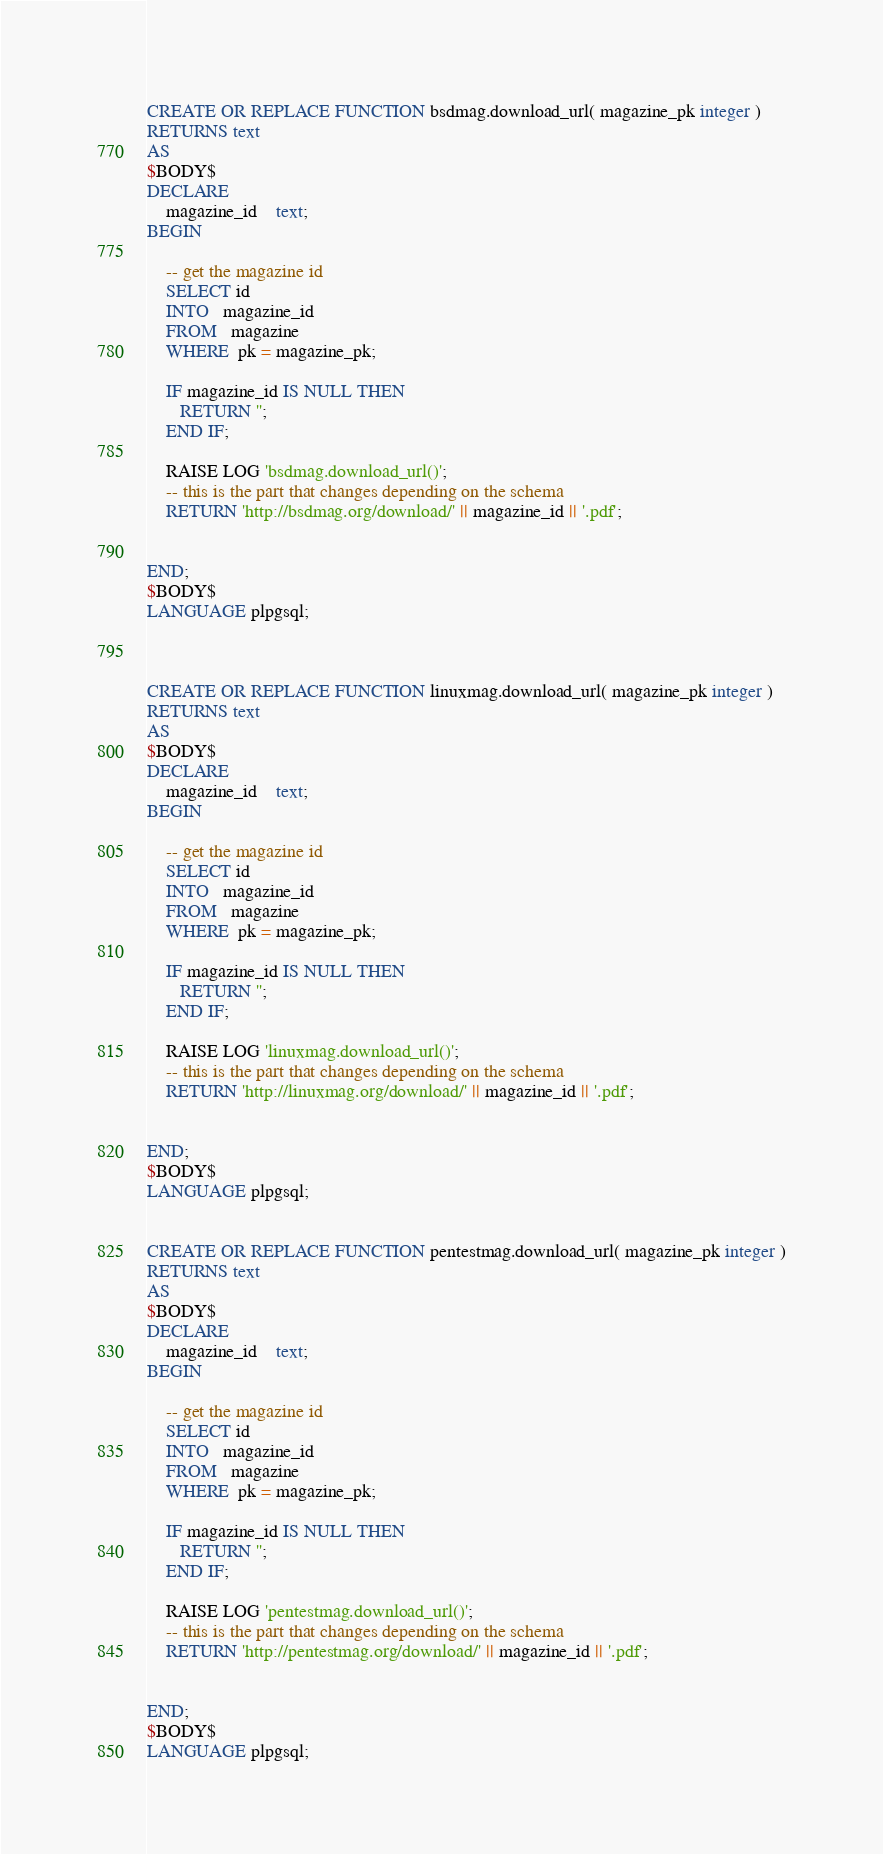<code> <loc_0><loc_0><loc_500><loc_500><_SQL_>CREATE OR REPLACE FUNCTION bsdmag.download_url( magazine_pk integer )
RETURNS text
AS
$BODY$
DECLARE
	magazine_id	text;
BEGIN

	-- get the magazine id
	SELECT id
	INTO   magazine_id
	FROM   magazine
	WHERE  pk = magazine_pk;

	IF magazine_id IS NULL THEN
	   RETURN '';
	END IF;
	
	RAISE LOG 'bsdmag.download_url()';
	-- this is the part that changes depending on the schema
	RETURN 'http://bsdmag.org/download/' || magazine_id || '.pdf';	
	

END;
$BODY$
LANGUAGE plpgsql;



CREATE OR REPLACE FUNCTION linuxmag.download_url( magazine_pk integer )
RETURNS text
AS
$BODY$
DECLARE
	magazine_id	text;
BEGIN

	-- get the magazine id
	SELECT id
	INTO   magazine_id
	FROM   magazine
	WHERE  pk = magazine_pk;

	IF magazine_id IS NULL THEN
	   RETURN '';
	END IF;

	RAISE LOG 'linuxmag.download_url()';
	-- this is the part that changes depending on the schema
	RETURN 'http://linuxmag.org/download/' || magazine_id || '.pdf';	
	

END;
$BODY$
LANGUAGE plpgsql;


CREATE OR REPLACE FUNCTION pentestmag.download_url( magazine_pk integer )
RETURNS text
AS
$BODY$
DECLARE
	magazine_id	text;
BEGIN

	-- get the magazine id
	SELECT id
	INTO   magazine_id
	FROM   magazine
	WHERE  pk = magazine_pk;

	IF magazine_id IS NULL THEN
	   RETURN '';
	END IF;

	RAISE LOG 'pentestmag.download_url()';
	-- this is the part that changes depending on the schema
	RETURN 'http://pentestmag.org/download/' || magazine_id || '.pdf';	
	

END;
$BODY$
LANGUAGE plpgsql;


</code> 